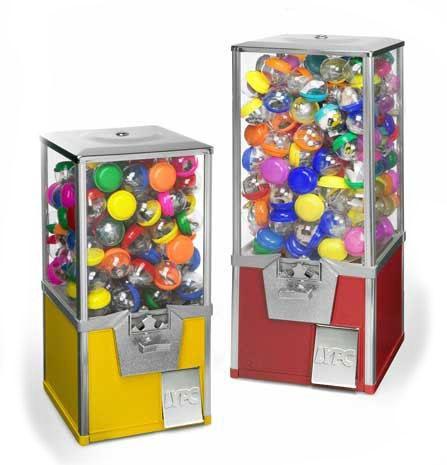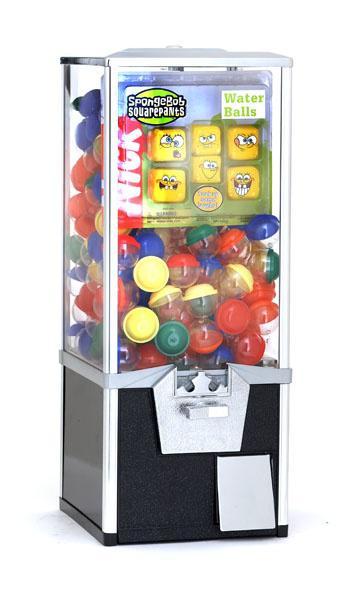The first image is the image on the left, the second image is the image on the right. For the images shown, is this caption "There are exactly 3 toy vending machines." true? Answer yes or no. Yes. 